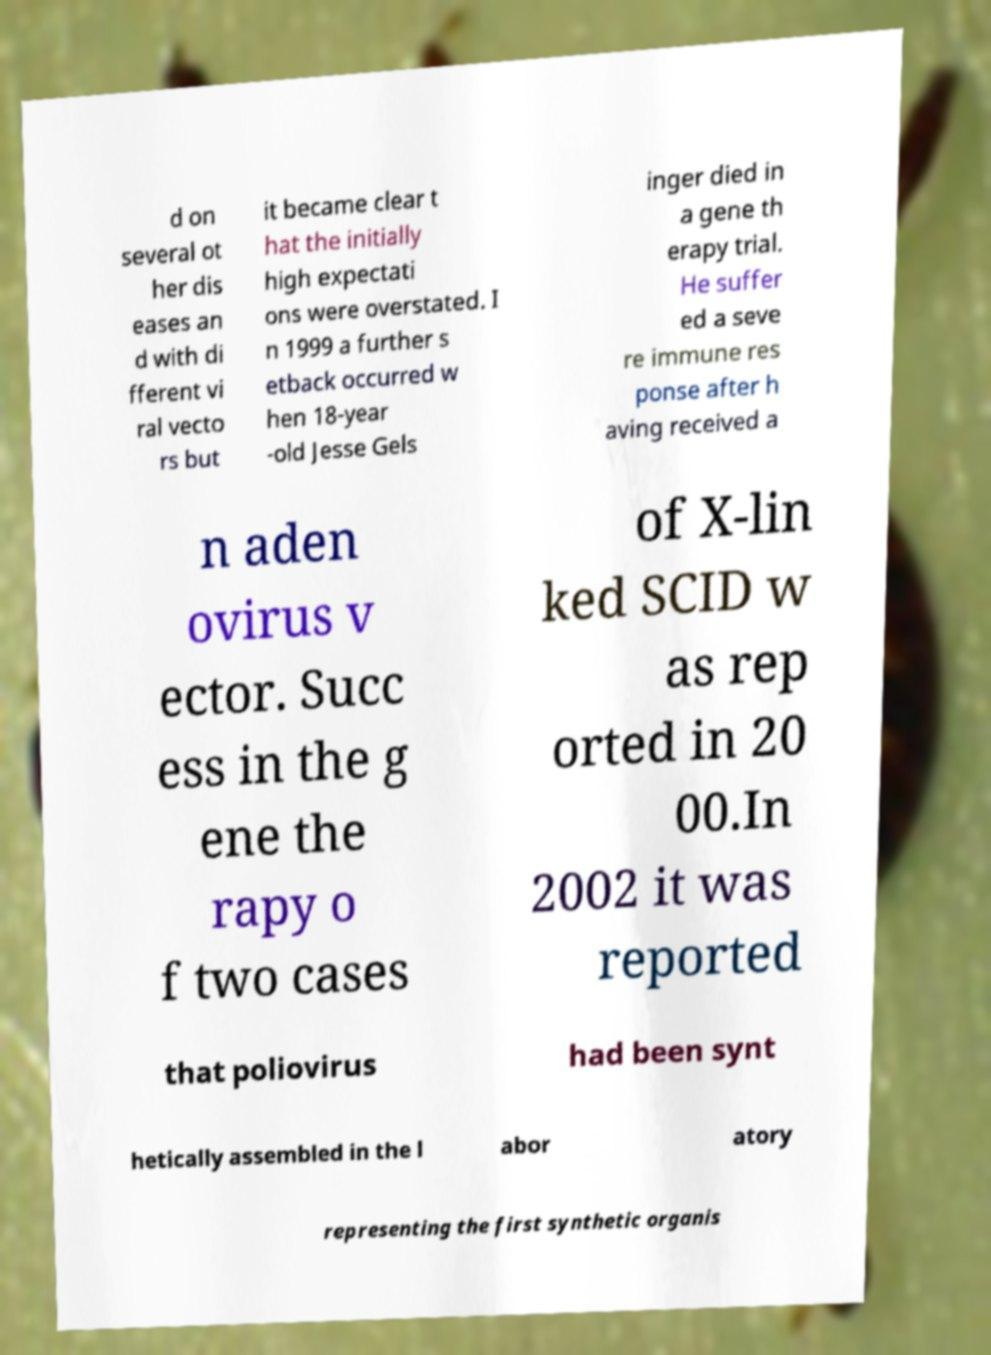Please identify and transcribe the text found in this image. d on several ot her dis eases an d with di fferent vi ral vecto rs but it became clear t hat the initially high expectati ons were overstated. I n 1999 a further s etback occurred w hen 18-year -old Jesse Gels inger died in a gene th erapy trial. He suffer ed a seve re immune res ponse after h aving received a n aden ovirus v ector. Succ ess in the g ene the rapy o f two cases of X-lin ked SCID w as rep orted in 20 00.In 2002 it was reported that poliovirus had been synt hetically assembled in the l abor atory representing the first synthetic organis 